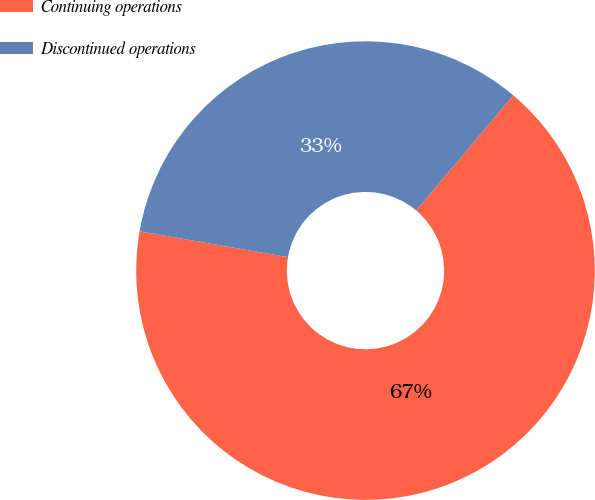Convert chart to OTSL. <chart><loc_0><loc_0><loc_500><loc_500><pie_chart><fcel>Continuing operations<fcel>Discontinued operations<nl><fcel>66.59%<fcel>33.41%<nl></chart> 